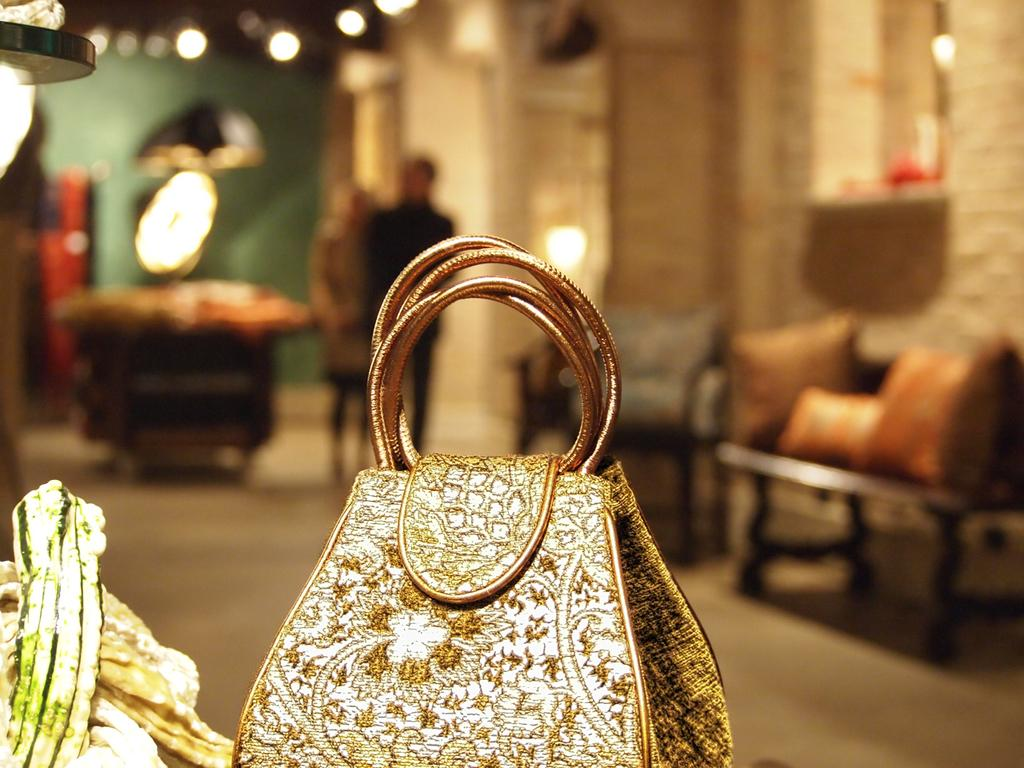What object is the main focus of the image? There is a handbag in the image. What can be seen in the background of the image? There are many lights, a sofa set, two persons, and a wall in the background of the image. What type of picture is hanging on the wall in the image? There is no picture hanging on the wall in the image; only a handbag and background elements are present. What is the power source for the lights in the background of the image? The power source for the lights is not visible in the image, and therefore it cannot be determined. 